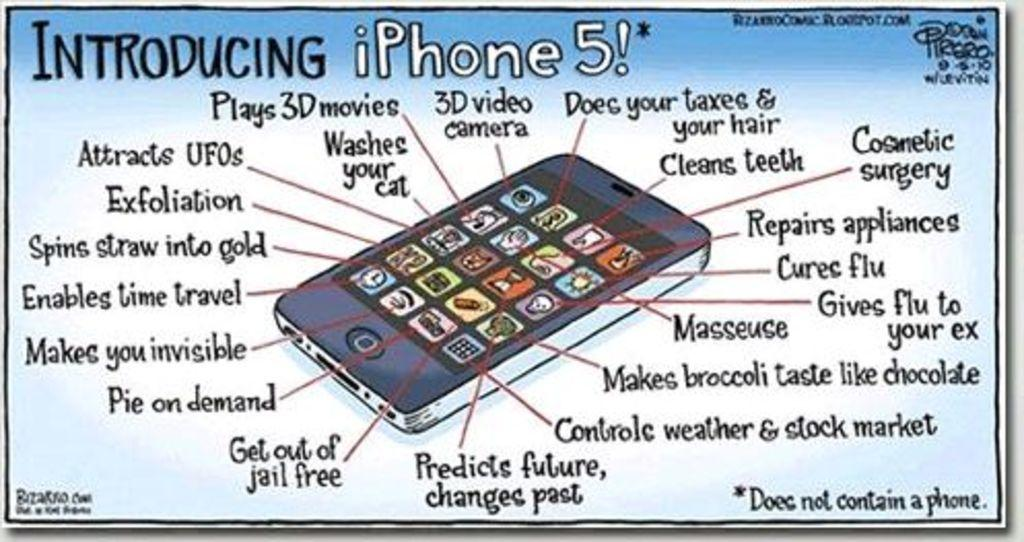<image>
Offer a succinct explanation of the picture presented. A hand drawn satire ad for an iPhone 5. 